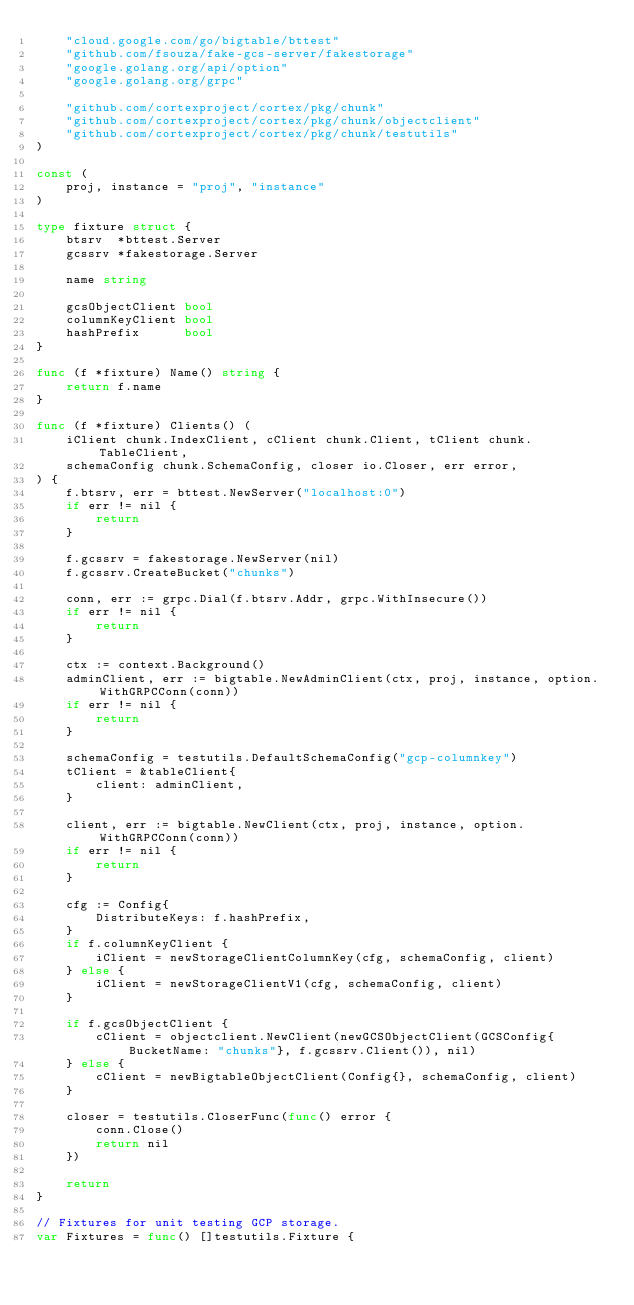<code> <loc_0><loc_0><loc_500><loc_500><_Go_>	"cloud.google.com/go/bigtable/bttest"
	"github.com/fsouza/fake-gcs-server/fakestorage"
	"google.golang.org/api/option"
	"google.golang.org/grpc"

	"github.com/cortexproject/cortex/pkg/chunk"
	"github.com/cortexproject/cortex/pkg/chunk/objectclient"
	"github.com/cortexproject/cortex/pkg/chunk/testutils"
)

const (
	proj, instance = "proj", "instance"
)

type fixture struct {
	btsrv  *bttest.Server
	gcssrv *fakestorage.Server

	name string

	gcsObjectClient bool
	columnKeyClient bool
	hashPrefix      bool
}

func (f *fixture) Name() string {
	return f.name
}

func (f *fixture) Clients() (
	iClient chunk.IndexClient, cClient chunk.Client, tClient chunk.TableClient,
	schemaConfig chunk.SchemaConfig, closer io.Closer, err error,
) {
	f.btsrv, err = bttest.NewServer("localhost:0")
	if err != nil {
		return
	}

	f.gcssrv = fakestorage.NewServer(nil)
	f.gcssrv.CreateBucket("chunks")

	conn, err := grpc.Dial(f.btsrv.Addr, grpc.WithInsecure())
	if err != nil {
		return
	}

	ctx := context.Background()
	adminClient, err := bigtable.NewAdminClient(ctx, proj, instance, option.WithGRPCConn(conn))
	if err != nil {
		return
	}

	schemaConfig = testutils.DefaultSchemaConfig("gcp-columnkey")
	tClient = &tableClient{
		client: adminClient,
	}

	client, err := bigtable.NewClient(ctx, proj, instance, option.WithGRPCConn(conn))
	if err != nil {
		return
	}

	cfg := Config{
		DistributeKeys: f.hashPrefix,
	}
	if f.columnKeyClient {
		iClient = newStorageClientColumnKey(cfg, schemaConfig, client)
	} else {
		iClient = newStorageClientV1(cfg, schemaConfig, client)
	}

	if f.gcsObjectClient {
		cClient = objectclient.NewClient(newGCSObjectClient(GCSConfig{BucketName: "chunks"}, f.gcssrv.Client()), nil)
	} else {
		cClient = newBigtableObjectClient(Config{}, schemaConfig, client)
	}

	closer = testutils.CloserFunc(func() error {
		conn.Close()
		return nil
	})

	return
}

// Fixtures for unit testing GCP storage.
var Fixtures = func() []testutils.Fixture {</code> 